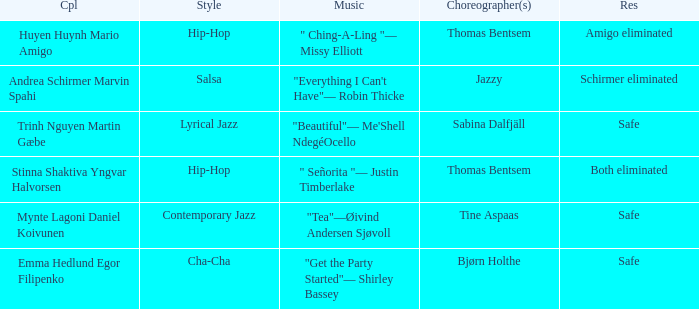Parse the full table. {'header': ['Cpl', 'Style', 'Music', 'Choreographer(s)', 'Res'], 'rows': [['Huyen Huynh Mario Amigo', 'Hip-Hop', '" Ching-A-Ling "— Missy Elliott', 'Thomas Bentsem', 'Amigo eliminated'], ['Andrea Schirmer Marvin Spahi', 'Salsa', '"Everything I Can\'t Have"— Robin Thicke', 'Jazzy', 'Schirmer eliminated'], ['Trinh Nguyen Martin Gæbe', 'Lyrical Jazz', '"Beautiful"— Me\'Shell NdegéOcello', 'Sabina Dalfjäll', 'Safe'], ['Stinna Shaktiva Yngvar Halvorsen', 'Hip-Hop', '" Señorita "— Justin Timberlake', 'Thomas Bentsem', 'Both eliminated'], ['Mynte Lagoni Daniel Koivunen', 'Contemporary Jazz', '"Tea"—Øivind Andersen Sjøvoll', 'Tine Aspaas', 'Safe'], ['Emma Hedlund Egor Filipenko', 'Cha-Cha', '"Get the Party Started"— Shirley Bassey', 'Bjørn Holthe', 'Safe']]} What is the music for choreographer sabina dalfjäll? "Beautiful"— Me'Shell NdegéOcello. 